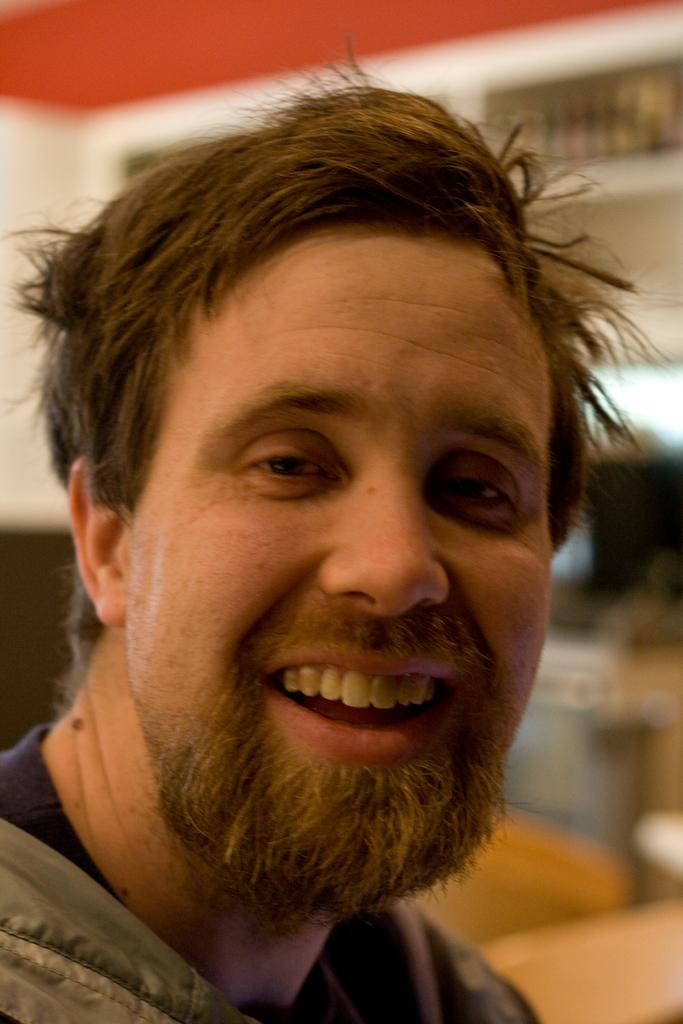What is the main subject of the image? There is a man in the image. What is the man's facial expression? The man is smiling. Can you describe the background of the image? The background of the image is blurry. What type of notebook is the man holding in the image? There is no notebook present in the image. What kind of lace can be seen on the man's clothing in the image? There is no lace visible on the man's clothing in the image. 